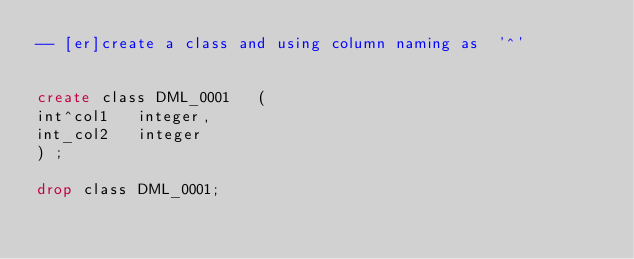Convert code to text. <code><loc_0><loc_0><loc_500><loc_500><_SQL_>-- [er]create a class and using column naming as  '^'


create class DML_0001 	( 
int^col1	 integer,
int_col2	 integer
)	;

drop class DML_0001;
</code> 